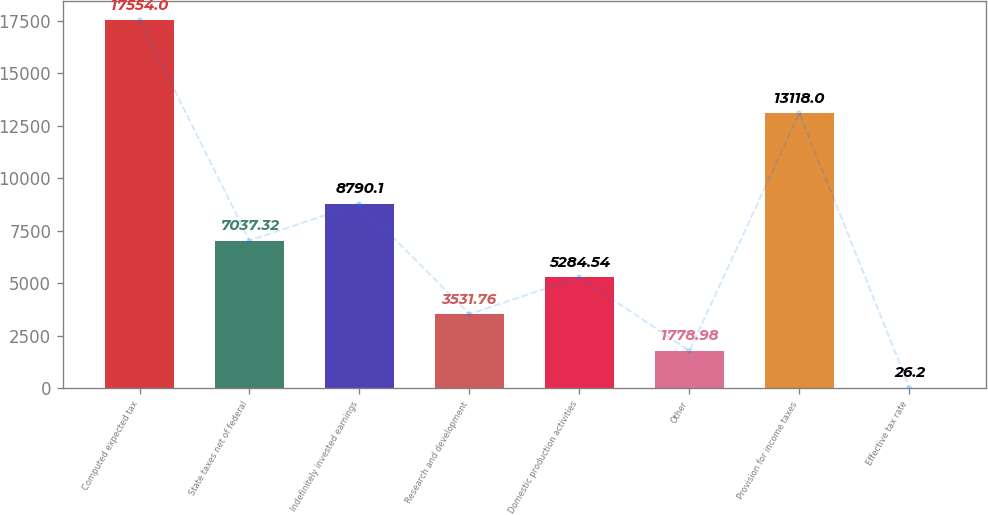Convert chart to OTSL. <chart><loc_0><loc_0><loc_500><loc_500><bar_chart><fcel>Computed expected tax<fcel>State taxes net of federal<fcel>Indefinitely invested earnings<fcel>Research and development<fcel>Domestic production activities<fcel>Other<fcel>Provision for income taxes<fcel>Effective tax rate<nl><fcel>17554<fcel>7037.32<fcel>8790.1<fcel>3531.76<fcel>5284.54<fcel>1778.98<fcel>13118<fcel>26.2<nl></chart> 